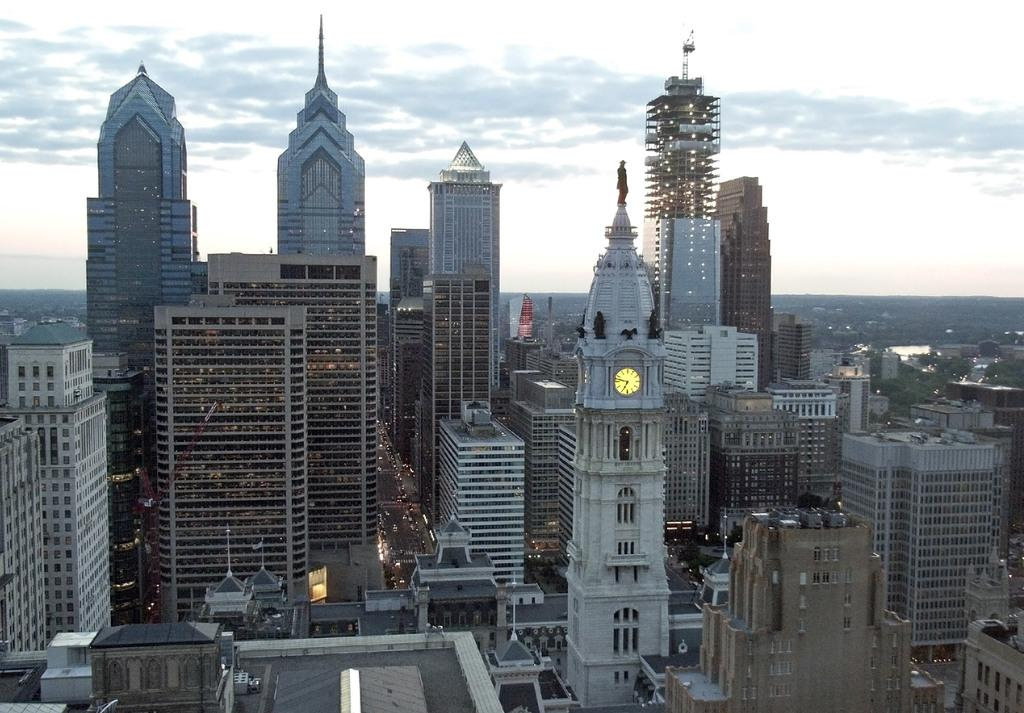What type of structures can be seen in the image? There are buildings in the image. What part of the natural environment is visible in the image? The sky is visible in the image. How would you describe the sky in the image? The sky is cloudy in the image. What type of berry can be seen growing on the buildings in the image? There are no berries visible on the buildings in the image. How does the vegetable contribute to the architectural design of the buildings in the image? There are no vegetables present in the image, so it cannot contribute to the architectural design. 